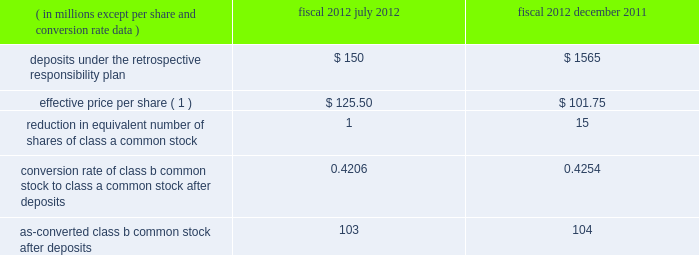Visa inc .
Notes to consolidated financial statements 2014 ( continued ) september 30 , 2013 in july 2013 , the company 2019s board of directors authorized a $ 1.5 billion share repurchase program to be in effect through july 2014 .
As of september 30 , 2013 , the program had remaining authorized funds of $ 251 million .
All share repurchase programs authorized prior to july 2013 have been completed .
In october 2013 , the company 2019s board of directors authorized a new $ 5.0 billion share repurchase program .
Under the terms of the retrospective responsibility plan , when the company makes a deposit into the litigation escrow account , the shares of class b common stock are subject to dilution through an adjustment to the conversion rate of the shares of class b common stock to shares of class a common stock .
These deposits have the same economic effect on earnings per share as repurchasing the company 2019s class a common stock , because they reduce the class b conversion rate and consequently the as-converted class a common stock share count .
The table presents as-converted class b common stock after deposits into the litigation escrow account in fiscal 2012 .
There were no deposits into the litigation escrow account in fiscal 2013. .
( 1 ) effective price per share calculated using the volume-weighted average price of the company 2019s class a common stock over a pricing period in accordance with the company 2019s current certificate of incorporation .
Class b common stock .
The class b common stock is not convertible or transferable until the date on which all of the covered litigation has been finally resolved .
This transfer restriction is subject to limited exceptions , including transfers to other holders of class b common stock .
After termination of the restrictions , the class b common stock will be convertible into class a common stock if transferred to a person that was not a visa member ( as defined in the current certificate of incorporation ) or similar person or an affiliate of a visa member or similar person .
Upon such transfer , each share of class b common stock will automatically convert into a number of shares of class a common stock based upon the applicable conversion rate in effect at the time of such transfer .
Adjustment of the conversion rate occurs upon : ( i ) the completion of any follow-on offering of class a common stock completed to increase the size of the litigation escrow account ( or any cash deposit by the company in lieu thereof ) resulting in a further corresponding decrease in the conversion rate ; or ( ii ) the final resolution of the covered litigation and the release of funds remaining on deposit in the litigation escrow account to the company resulting in a corresponding increase in the conversion rate. .
What is the percentage change in the effective price per share from december 2011 to july 2012? 
Computations: ((125.50 - 101.75) / 101.75)
Answer: 0.23342. 